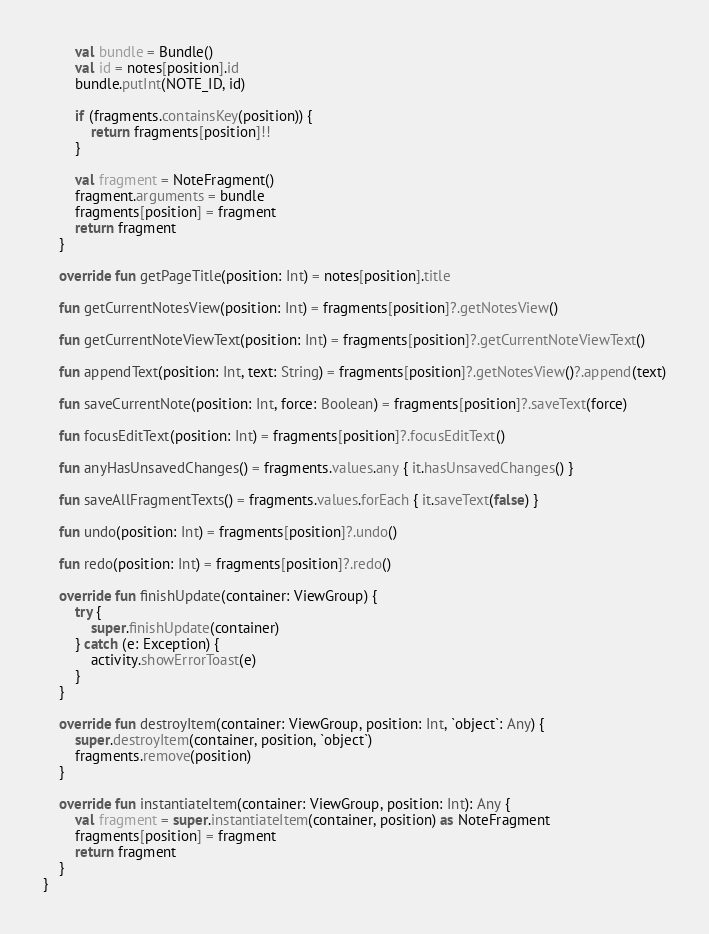Convert code to text. <code><loc_0><loc_0><loc_500><loc_500><_Kotlin_>        val bundle = Bundle()
        val id = notes[position].id
        bundle.putInt(NOTE_ID, id)

        if (fragments.containsKey(position)) {
            return fragments[position]!!
        }

        val fragment = NoteFragment()
        fragment.arguments = bundle
        fragments[position] = fragment
        return fragment
    }

    override fun getPageTitle(position: Int) = notes[position].title

    fun getCurrentNotesView(position: Int) = fragments[position]?.getNotesView()

    fun getCurrentNoteViewText(position: Int) = fragments[position]?.getCurrentNoteViewText()

    fun appendText(position: Int, text: String) = fragments[position]?.getNotesView()?.append(text)

    fun saveCurrentNote(position: Int, force: Boolean) = fragments[position]?.saveText(force)

    fun focusEditText(position: Int) = fragments[position]?.focusEditText()

    fun anyHasUnsavedChanges() = fragments.values.any { it.hasUnsavedChanges() }

    fun saveAllFragmentTexts() = fragments.values.forEach { it.saveText(false) }

    fun undo(position: Int) = fragments[position]?.undo()

    fun redo(position: Int) = fragments[position]?.redo()

    override fun finishUpdate(container: ViewGroup) {
        try {
            super.finishUpdate(container)
        } catch (e: Exception) {
            activity.showErrorToast(e)
        }
    }

    override fun destroyItem(container: ViewGroup, position: Int, `object`: Any) {
        super.destroyItem(container, position, `object`)
        fragments.remove(position)
    }

    override fun instantiateItem(container: ViewGroup, position: Int): Any {
        val fragment = super.instantiateItem(container, position) as NoteFragment
        fragments[position] = fragment
        return fragment
    }
}
</code> 